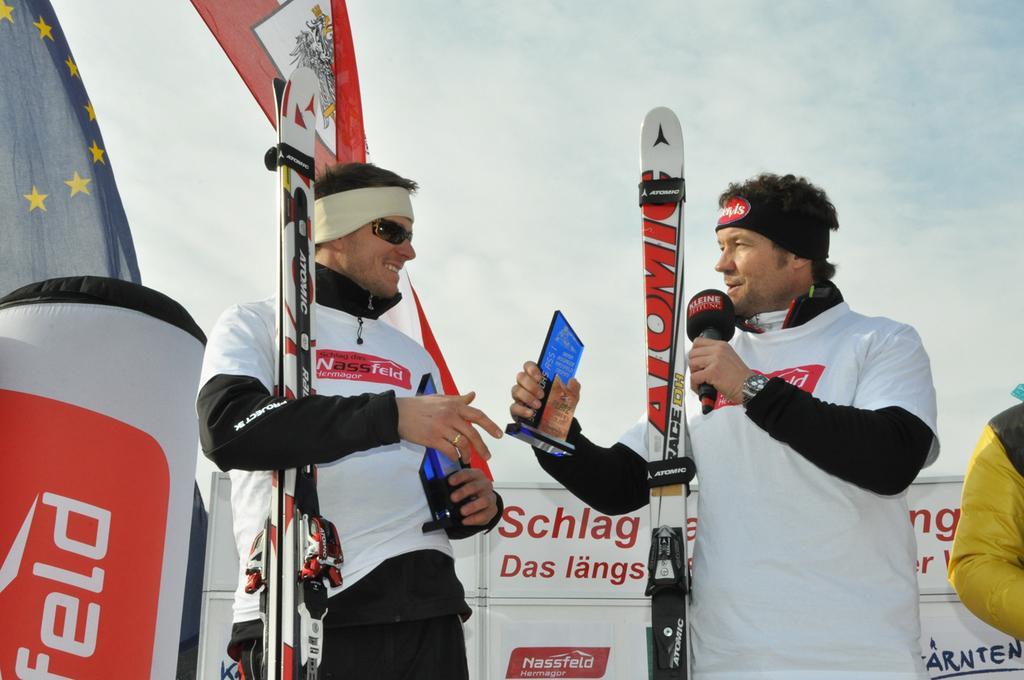In one or two sentences, can you explain what this image depicts? In this image i can see 2 persons standing and holding the ski board in their hands. In the background i can see the sky a flag and few banners. 